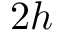Convert formula to latex. <formula><loc_0><loc_0><loc_500><loc_500>2 h</formula> 